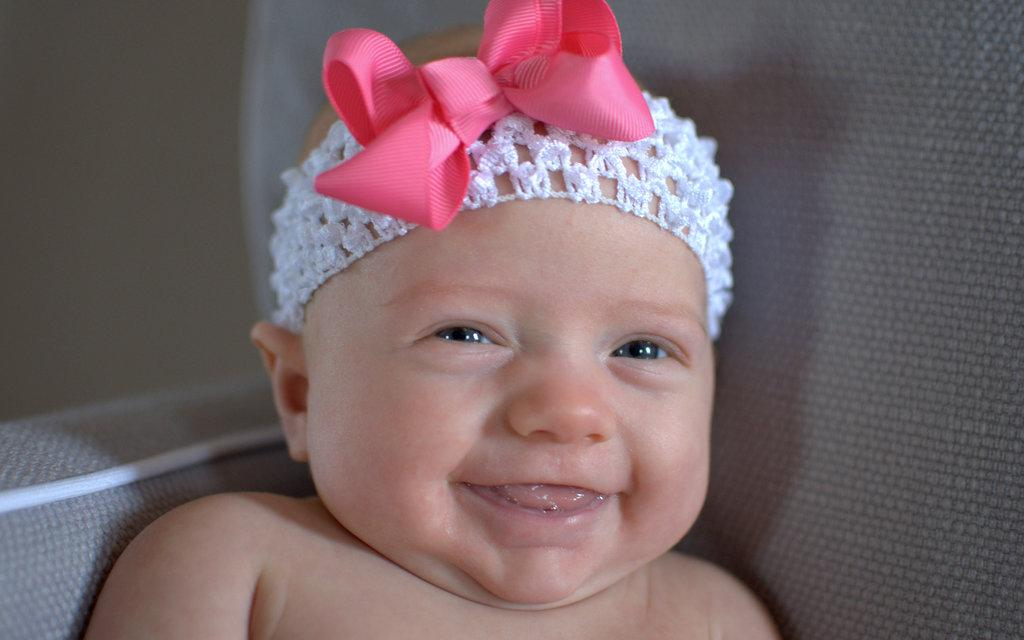What is the main subject of the picture? The main subject of the picture is a baby. What is the baby doing in the picture? The baby is sitting on a chair and smiling. What type of cave can be seen in the background of the picture? There is no cave present in the image; it features a baby sitting on a chair and smiling. 